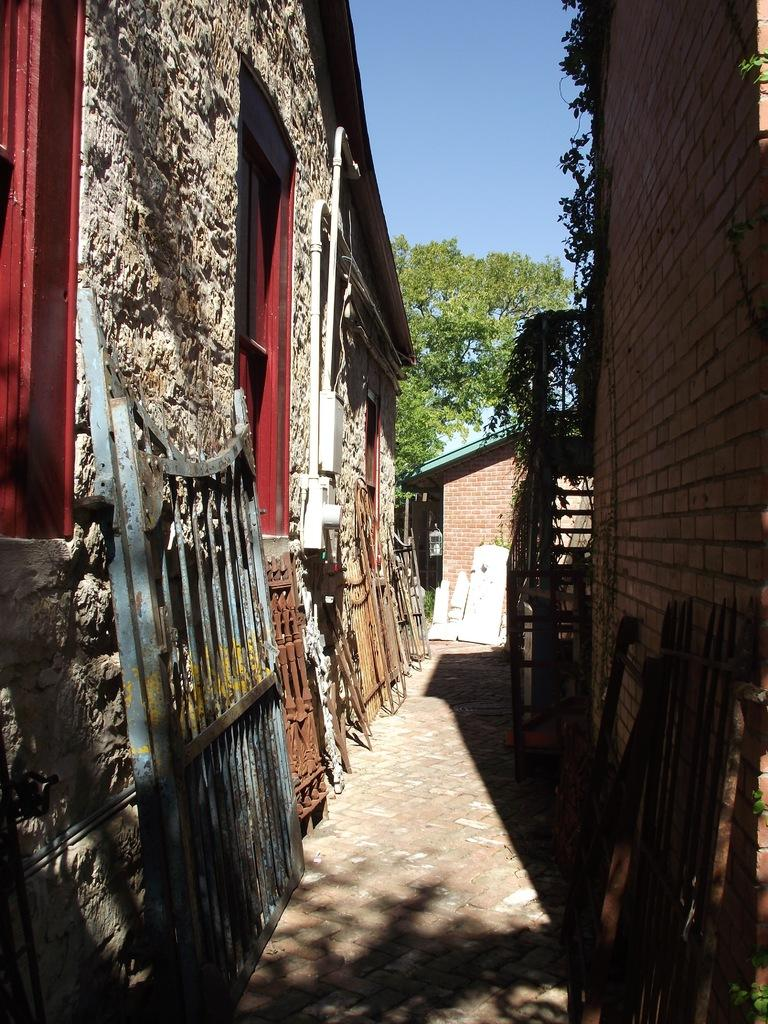How many houses are present in the image? There are two houses in the image. What other natural element can be seen in the image besides the houses? There is a tree in the image. What is the color of the sky in the image? The sky is blue in the image. Is there a way to travel between the houses in the image? Yes, there is a path in the image. What can be found on the side of the houses? There are objects on the side of the houses. Can you see an airplane flying over the houses in the image? No, there is no airplane visible in the image. 